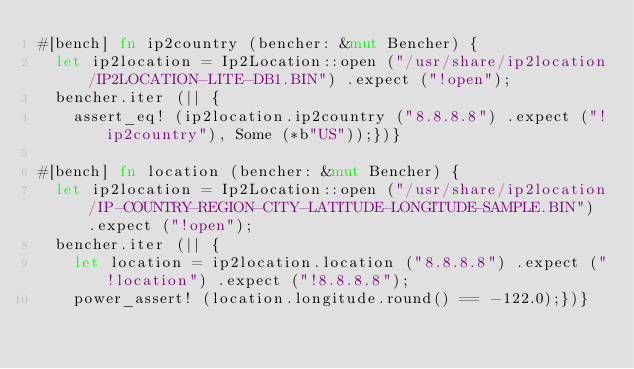<code> <loc_0><loc_0><loc_500><loc_500><_Rust_>#[bench] fn ip2country (bencher: &mut Bencher) {
  let ip2location = Ip2Location::open ("/usr/share/ip2location/IP2LOCATION-LITE-DB1.BIN") .expect ("!open");
  bencher.iter (|| {
    assert_eq! (ip2location.ip2country ("8.8.8.8") .expect ("!ip2country"), Some (*b"US"));})}

#[bench] fn location (bencher: &mut Bencher) {
  let ip2location = Ip2Location::open ("/usr/share/ip2location/IP-COUNTRY-REGION-CITY-LATITUDE-LONGITUDE-SAMPLE.BIN") .expect ("!open");
  bencher.iter (|| {
    let location = ip2location.location ("8.8.8.8") .expect ("!location") .expect ("!8.8.8.8");
    power_assert! (location.longitude.round() == -122.0);})}
</code> 